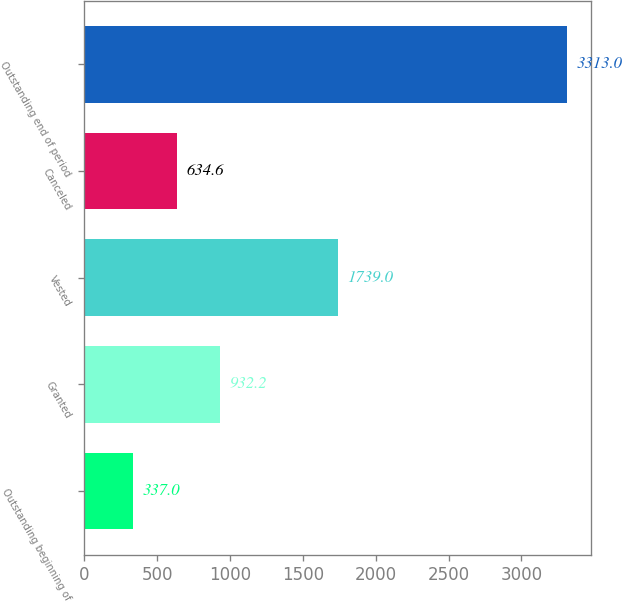Convert chart. <chart><loc_0><loc_0><loc_500><loc_500><bar_chart><fcel>Outstanding beginning of<fcel>Granted<fcel>Vested<fcel>Canceled<fcel>Outstanding end of period<nl><fcel>337<fcel>932.2<fcel>1739<fcel>634.6<fcel>3313<nl></chart> 